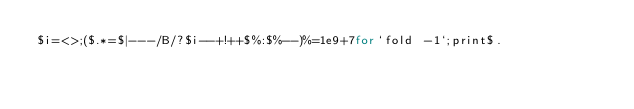Convert code to text. <code><loc_0><loc_0><loc_500><loc_500><_Perl_>$i=<>;($.*=$|---/B/?$i--+!++$%:$%--)%=1e9+7for`fold -1`;print$.</code> 